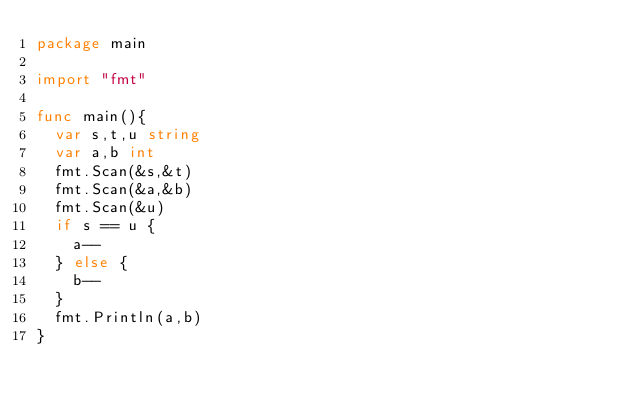<code> <loc_0><loc_0><loc_500><loc_500><_Go_>package main

import "fmt"

func main(){
	var s,t,u string
	var a,b int
	fmt.Scan(&s,&t)
	fmt.Scan(&a,&b)
	fmt.Scan(&u)
	if s == u {
		a--
	} else {
		b--
	}
	fmt.Println(a,b)
}
</code> 